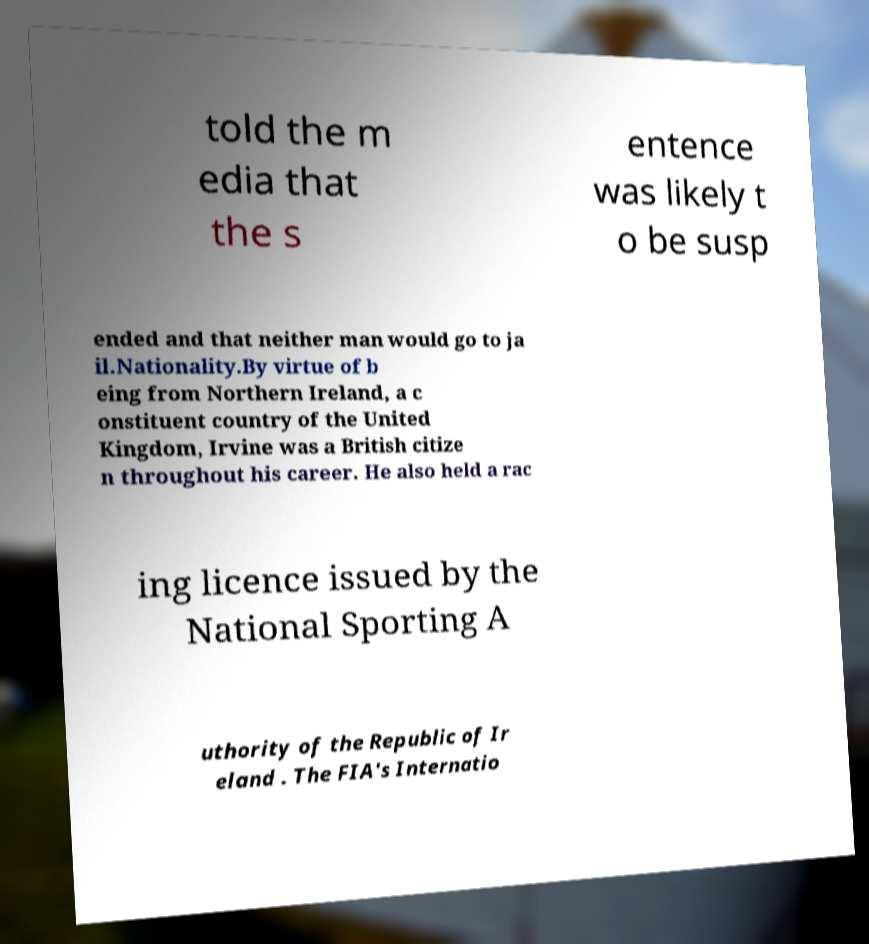Could you assist in decoding the text presented in this image and type it out clearly? told the m edia that the s entence was likely t o be susp ended and that neither man would go to ja il.Nationality.By virtue of b eing from Northern Ireland, a c onstituent country of the United Kingdom, Irvine was a British citize n throughout his career. He also held a rac ing licence issued by the National Sporting A uthority of the Republic of Ir eland . The FIA's Internatio 